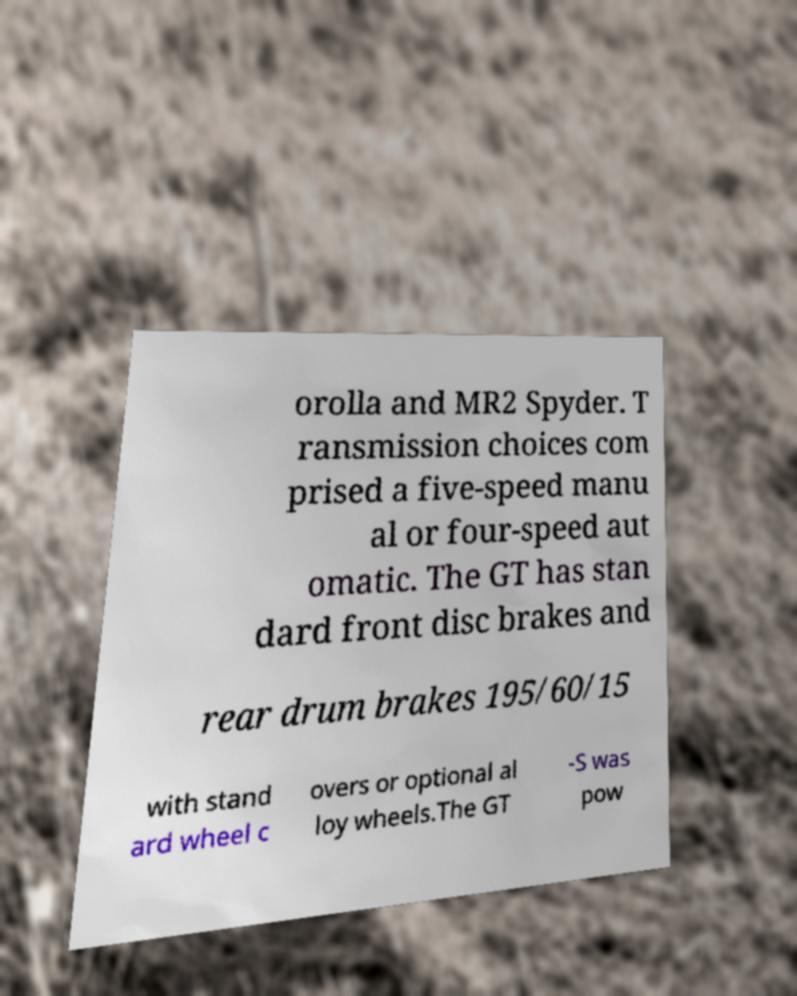Can you accurately transcribe the text from the provided image for me? orolla and MR2 Spyder. T ransmission choices com prised a five-speed manu al or four-speed aut omatic. The GT has stan dard front disc brakes and rear drum brakes 195/60/15 with stand ard wheel c overs or optional al loy wheels.The GT -S was pow 